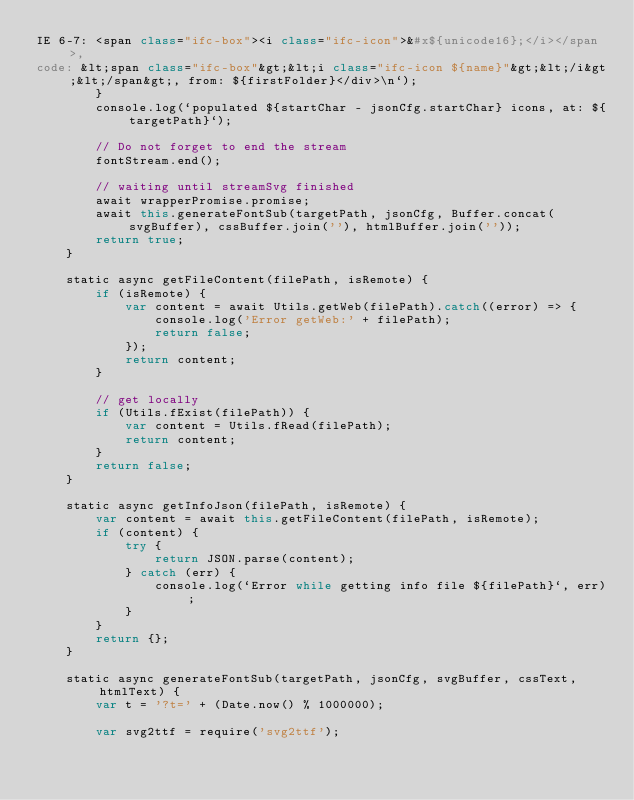<code> <loc_0><loc_0><loc_500><loc_500><_JavaScript_>IE 6-7: <span class="ifc-box"><i class="ifc-icon">&#x${unicode16};</i></span>, 
code: &lt;span class="ifc-box"&gt;&lt;i class="ifc-icon ${name}"&gt;&lt;/i&gt;&lt;/span&gt;, from: ${firstFolder}</div>\n`);
        }
        console.log(`populated ${startChar - jsonCfg.startChar} icons, at: ${targetPath}`);

        // Do not forget to end the stream
        fontStream.end();

        // waiting until streamSvg finished
        await wrapperPromise.promise;
        await this.generateFontSub(targetPath, jsonCfg, Buffer.concat(svgBuffer), cssBuffer.join(''), htmlBuffer.join(''));
        return true;
    }

    static async getFileContent(filePath, isRemote) {
        if (isRemote) {
            var content = await Utils.getWeb(filePath).catch((error) => {
                console.log('Error getWeb:' + filePath);
                return false;
            });
            return content;
        }

        // get locally
        if (Utils.fExist(filePath)) {
            var content = Utils.fRead(filePath);
            return content;
        }
        return false;
    }

    static async getInfoJson(filePath, isRemote) {
        var content = await this.getFileContent(filePath, isRemote);
        if (content) {
            try {
                return JSON.parse(content);
            } catch (err) {
                console.log(`Error while getting info file ${filePath}`, err);
            }
        }
        return {};
    }

    static async generateFontSub(targetPath, jsonCfg, svgBuffer, cssText, htmlText) {
        var t = '?t=' + (Date.now() % 1000000);

        var svg2ttf = require('svg2ttf');</code> 